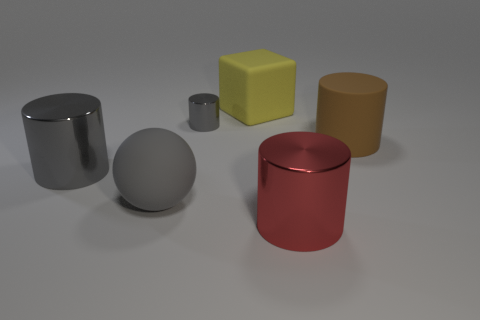What number of big objects are cyan spheres or cubes?
Your answer should be very brief. 1. There is a big thing to the right of the red cylinder; is it the same shape as the tiny gray metal thing?
Your answer should be very brief. Yes. Are there fewer big green blocks than spheres?
Keep it short and to the point. Yes. Are there any other things that are the same color as the big rubber ball?
Your response must be concise. Yes. There is a large matte thing behind the small cylinder; what shape is it?
Give a very brief answer. Cube. Does the big sphere have the same color as the large metallic cylinder that is on the left side of the big red metal object?
Ensure brevity in your answer.  Yes. Is the number of objects to the right of the small gray shiny cylinder the same as the number of shiny things behind the big gray cylinder?
Keep it short and to the point. No. What number of other objects are the same size as the gray matte thing?
Your response must be concise. 4. Does the big yellow object have the same material as the big cylinder left of the red metallic thing?
Your response must be concise. No. Is there a brown matte thing of the same shape as the big gray metal thing?
Provide a succinct answer. Yes. 